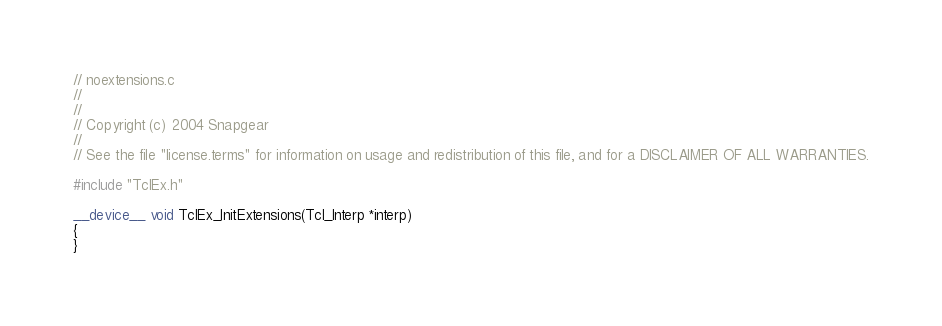Convert code to text. <code><loc_0><loc_0><loc_500><loc_500><_Cuda_>// noextensions.c
//
//
// Copyright (c) 2004 Snapgear
//
// See the file "license.terms" for information on usage and redistribution of this file, and for a DISCLAIMER OF ALL WARRANTIES.

#include "TclEx.h"

__device__ void TclEx_InitExtensions(Tcl_Interp *interp)
{
}
</code> 